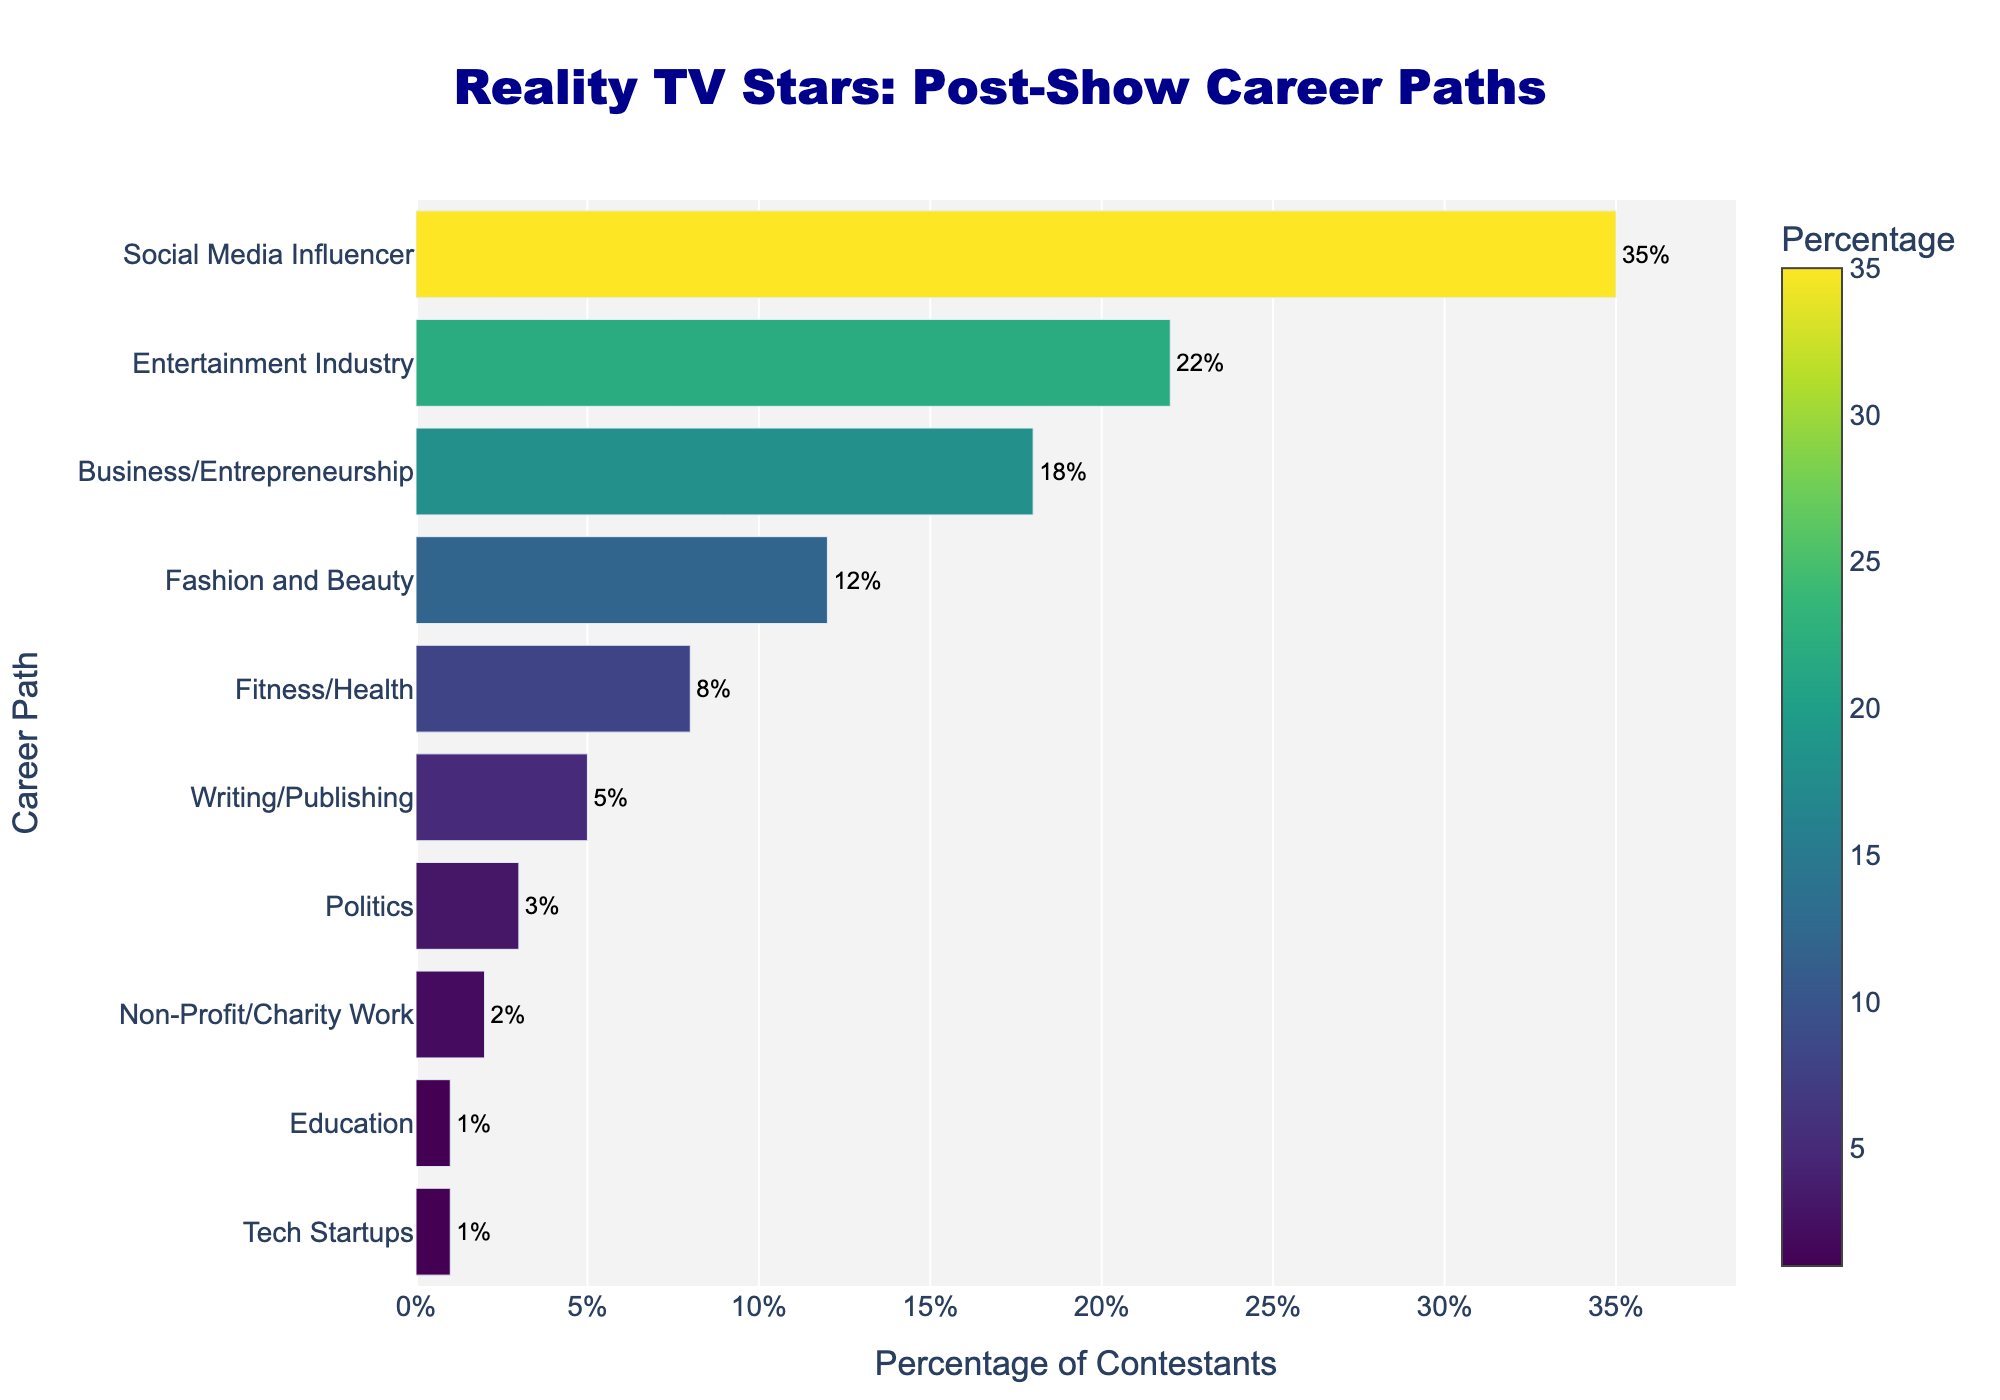Which career path is the most common for reality TV stars? The chart shows that "Social Media Influencer" has the highest percentage bar, making it the most common career path.
Answer: Social Media Influencer Which two career paths have the lowest percentage? From the bar lengths, "Education" and "Tech Startups" both show the smallest percentages in the chart.
Answer: Education and Tech Startups How many career paths have a percentage of 10% or higher? The career paths above 10% are "Social Media Influencer," "Entertainment Industry," "Business/Entrepreneurship," and "Fashion and Beauty." This makes four career paths.
Answer: 4 What is the combined percentage of contestants in Business/Entrepreneurship and Fashion and Beauty? The bar for Business/Entrepreneurship shows 18%, and the bar for Fashion and Beauty shows 12%. Adding these together is 18% + 12% = 30%.
Answer: 30% Which career path has a higher percentage, Fitness/Health or Writing/Publishing? By comparing the bar lengths, the "Fitness/Health" path is higher than "Writing/Publishing," indicating a higher percentage.
Answer: Fitness/Health What is the difference in percentage between Social Media Influencer and Entertainment Industry? The percentage for Social Media Influencer is 35%, and for Entertainment Industry, it is 22%. The difference is 35% - 22% = 13%.
Answer: 13% Which career path is the least pursued by contestants, excluding Education and Tech Startups? Excluding Education and Tech Startups which both have 1%, the next smallest bar is "Non-Profit/Charity Work" with 2%.
Answer: Non-Profit/Charity Work What percentage of contestants are involved in either Politics or Non-Profit/Charity Work? Adding the percentages for Politics (3%) and Non-Profit/Charity Work (2%) gives 3% + 2% = 5%.
Answer: 5% Which career path has the fifth-highest percentage? Based on the declining order of the bars, the fifth highest is "Fitness/Health" at 8%.
Answer: Fitness/Health 